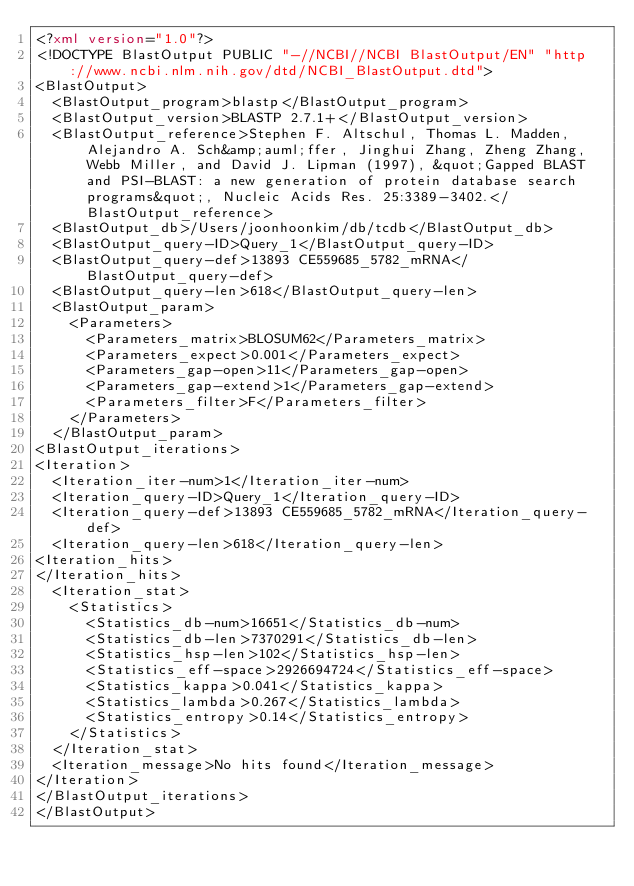Convert code to text. <code><loc_0><loc_0><loc_500><loc_500><_XML_><?xml version="1.0"?>
<!DOCTYPE BlastOutput PUBLIC "-//NCBI//NCBI BlastOutput/EN" "http://www.ncbi.nlm.nih.gov/dtd/NCBI_BlastOutput.dtd">
<BlastOutput>
  <BlastOutput_program>blastp</BlastOutput_program>
  <BlastOutput_version>BLASTP 2.7.1+</BlastOutput_version>
  <BlastOutput_reference>Stephen F. Altschul, Thomas L. Madden, Alejandro A. Sch&amp;auml;ffer, Jinghui Zhang, Zheng Zhang, Webb Miller, and David J. Lipman (1997), &quot;Gapped BLAST and PSI-BLAST: a new generation of protein database search programs&quot;, Nucleic Acids Res. 25:3389-3402.</BlastOutput_reference>
  <BlastOutput_db>/Users/joonhoonkim/db/tcdb</BlastOutput_db>
  <BlastOutput_query-ID>Query_1</BlastOutput_query-ID>
  <BlastOutput_query-def>13893 CE559685_5782_mRNA</BlastOutput_query-def>
  <BlastOutput_query-len>618</BlastOutput_query-len>
  <BlastOutput_param>
    <Parameters>
      <Parameters_matrix>BLOSUM62</Parameters_matrix>
      <Parameters_expect>0.001</Parameters_expect>
      <Parameters_gap-open>11</Parameters_gap-open>
      <Parameters_gap-extend>1</Parameters_gap-extend>
      <Parameters_filter>F</Parameters_filter>
    </Parameters>
  </BlastOutput_param>
<BlastOutput_iterations>
<Iteration>
  <Iteration_iter-num>1</Iteration_iter-num>
  <Iteration_query-ID>Query_1</Iteration_query-ID>
  <Iteration_query-def>13893 CE559685_5782_mRNA</Iteration_query-def>
  <Iteration_query-len>618</Iteration_query-len>
<Iteration_hits>
</Iteration_hits>
  <Iteration_stat>
    <Statistics>
      <Statistics_db-num>16651</Statistics_db-num>
      <Statistics_db-len>7370291</Statistics_db-len>
      <Statistics_hsp-len>102</Statistics_hsp-len>
      <Statistics_eff-space>2926694724</Statistics_eff-space>
      <Statistics_kappa>0.041</Statistics_kappa>
      <Statistics_lambda>0.267</Statistics_lambda>
      <Statistics_entropy>0.14</Statistics_entropy>
    </Statistics>
  </Iteration_stat>
  <Iteration_message>No hits found</Iteration_message>
</Iteration>
</BlastOutput_iterations>
</BlastOutput>

</code> 